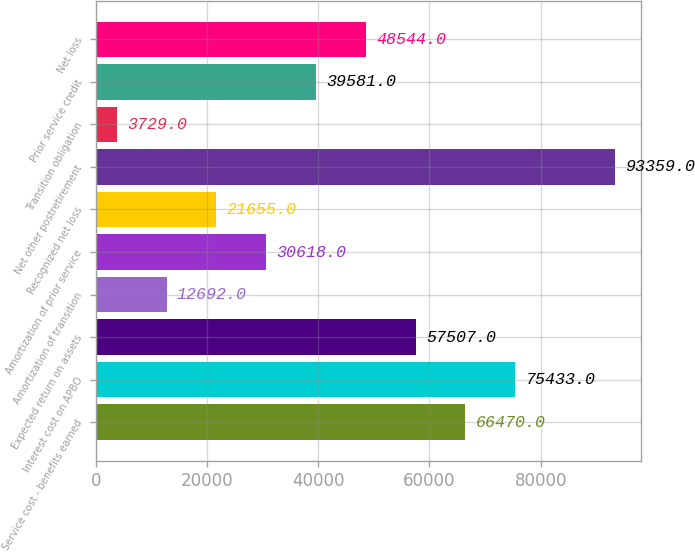Convert chart. <chart><loc_0><loc_0><loc_500><loc_500><bar_chart><fcel>Service cost - benefits earned<fcel>Interest cost on APBO<fcel>Expected return on assets<fcel>Amortization of transition<fcel>Amortization of prior service<fcel>Recognized net loss<fcel>Net other postretirement<fcel>Transition obligation<fcel>Prior service credit<fcel>Net loss<nl><fcel>66470<fcel>75433<fcel>57507<fcel>12692<fcel>30618<fcel>21655<fcel>93359<fcel>3729<fcel>39581<fcel>48544<nl></chart> 